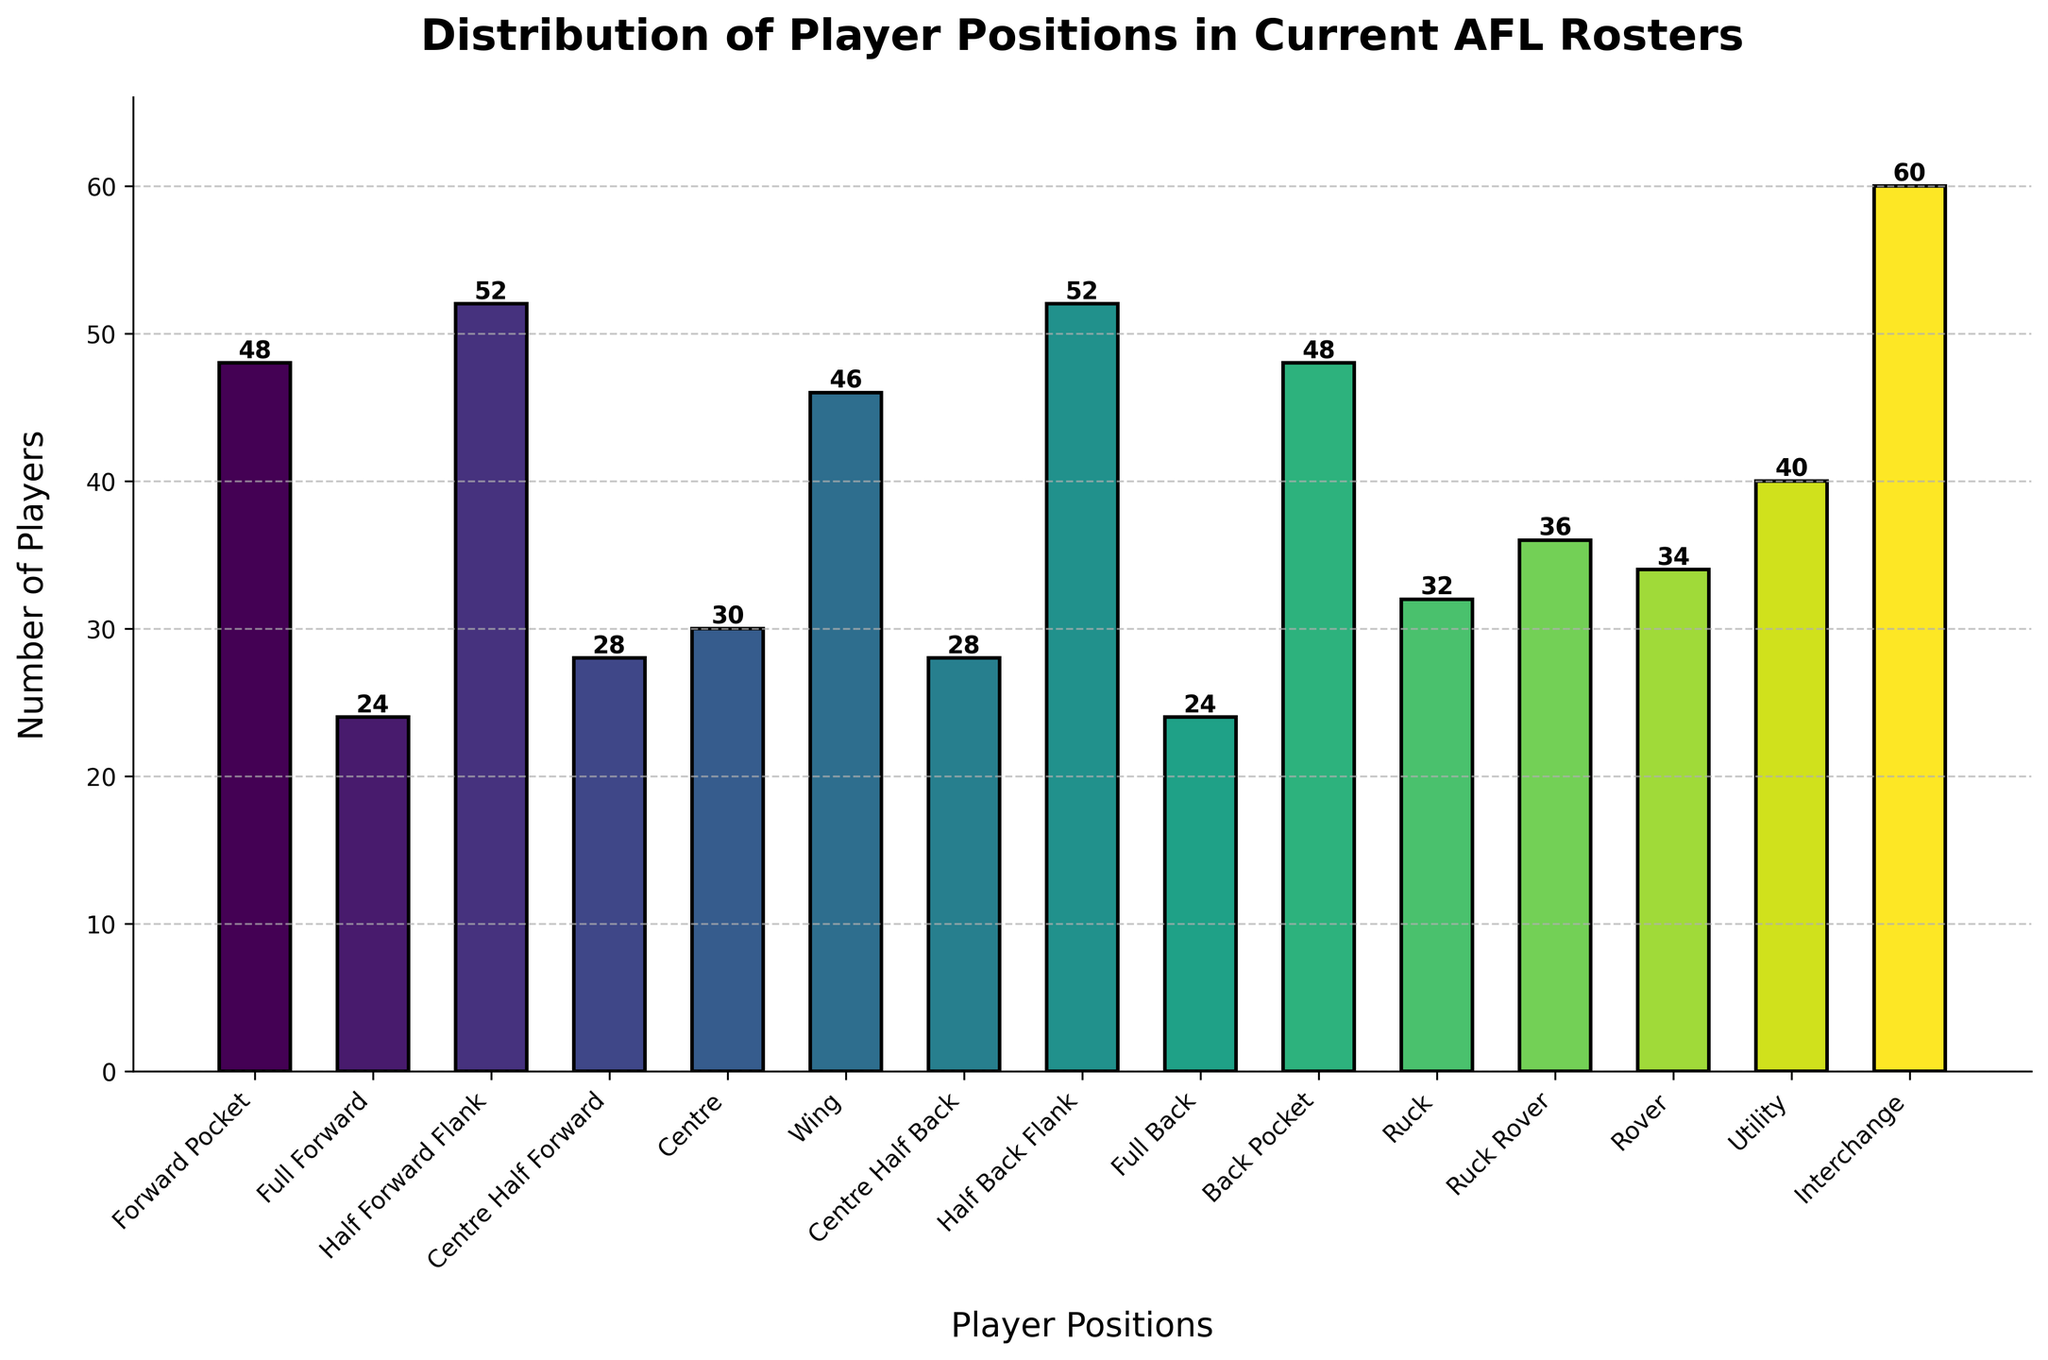Which player position has the highest number of players in the current AFL rosters? The tallest bar in the figure corresponds to the position with the highest number of players, which is the Interchange position.
Answer: Interchange Which two player positions have an equal number of players? By comparing the lengths of the bars, we can see that Forward Pocket and Back Pocket each have 48 players, and Full Forward and Full Back each have 24 players.
Answer: Forward Pocket and Back Pocket, Full Forward and Full Back How many more players are there in the Half Forward Flank position compared to the Centre Half Back position? The number of players in the Half Forward Flank position is 52, while the Centre Half Back position has 28 players. Subtracting the latter from the former gives \(52 - 28 = 24\).
Answer: 24 What is the average number of players per position? Summing the number of players across all positions \(48 + 24 + 52 + 28 + 30 + 46 + 28 + 52 + 24 + 48 + 32 + 36 + 34 + 40 + 60 = 582\) and then dividing by the total number of positions (15), we get \(\frac{582}{15} ≈ 38.8\).
Answer: 38.8 How does the number of players in the Ruck position compare to the number of players in the Ruck Rover position? The number of players in the Ruck position is 32, while the number of players in the Ruck Rover position is 36. The Ruck Rover position has 36 - 32 = 4 more players than the Ruck position.
Answer: 4 more players in the Ruck Rover position What is the median value of the number of players across all positions? To find the median, list the number of players in ascending order: \(24, 24, 28, 28, 30, 32, 34, 36, 40, 46, 48, 48, 52, 52, 60\). The median is the middle value, which is the 8th value: 36.
Answer: 36 What is the total number of players in defensive positions (Back Pocket, Full Back, Centre Half Back, Half Back Flank)? Adding the players in these positions: \(48 (Back Pocket) + 24 (Full Back) + 28 (Centre Half Back) + 52 (Half Back Flank) = 152\).
Answer: 152 Which position has exactly half the number of players as the Interchange position? The Interchange position has 60 players. Half of this is \( \frac{60}{2} = 30\). The Centre position has exactly 30 players.
Answer: Centre If we consider Utility players as part of defensive positions, how many total players are in defensive positions now? Previously, the count was 152. Adding the Utility players (40), we get \(152 + 40 = 192\).
Answer: 192 